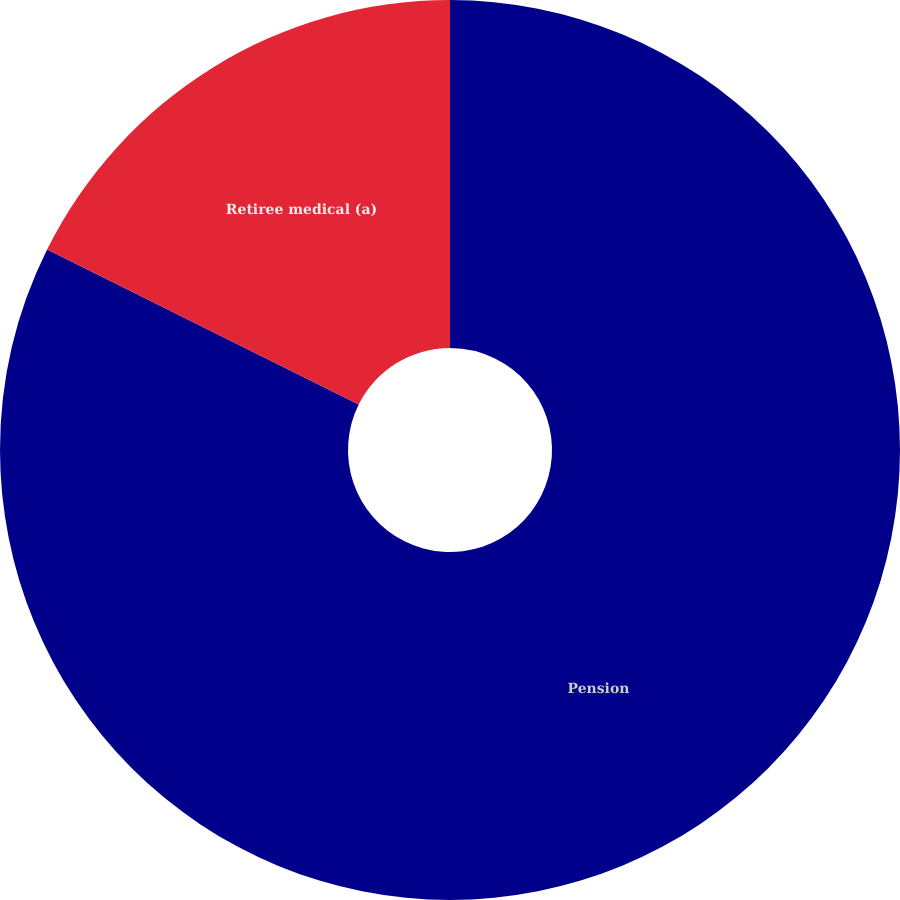<chart> <loc_0><loc_0><loc_500><loc_500><pie_chart><fcel>Pension<fcel>Retiree medical (a)<nl><fcel>82.35%<fcel>17.65%<nl></chart> 